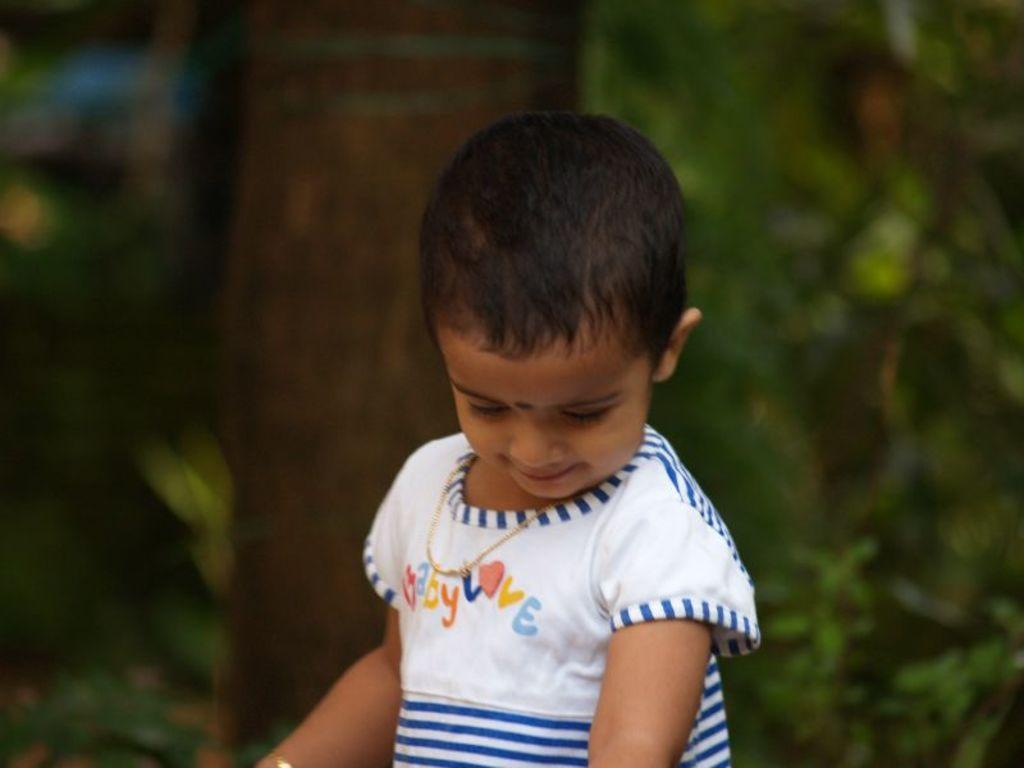What is the main subject of the image? The main subject of the image is a kid. Where is the kid located in the image? The kid is in the center of the image. What is the kid wearing in the image? The kid is wearing a white dress. Can you describe the background of the image? The background of the image is blurred. What type of locket can be seen hanging from the kid's neck in the image? There is no locket visible hanging from the kid's neck in the image. Is the kid holding a pipe in the image? There is no pipe present in the image. What type of gun is visible in the kid's hand in the image? There is no gun visible in the kid's hand in the image. 